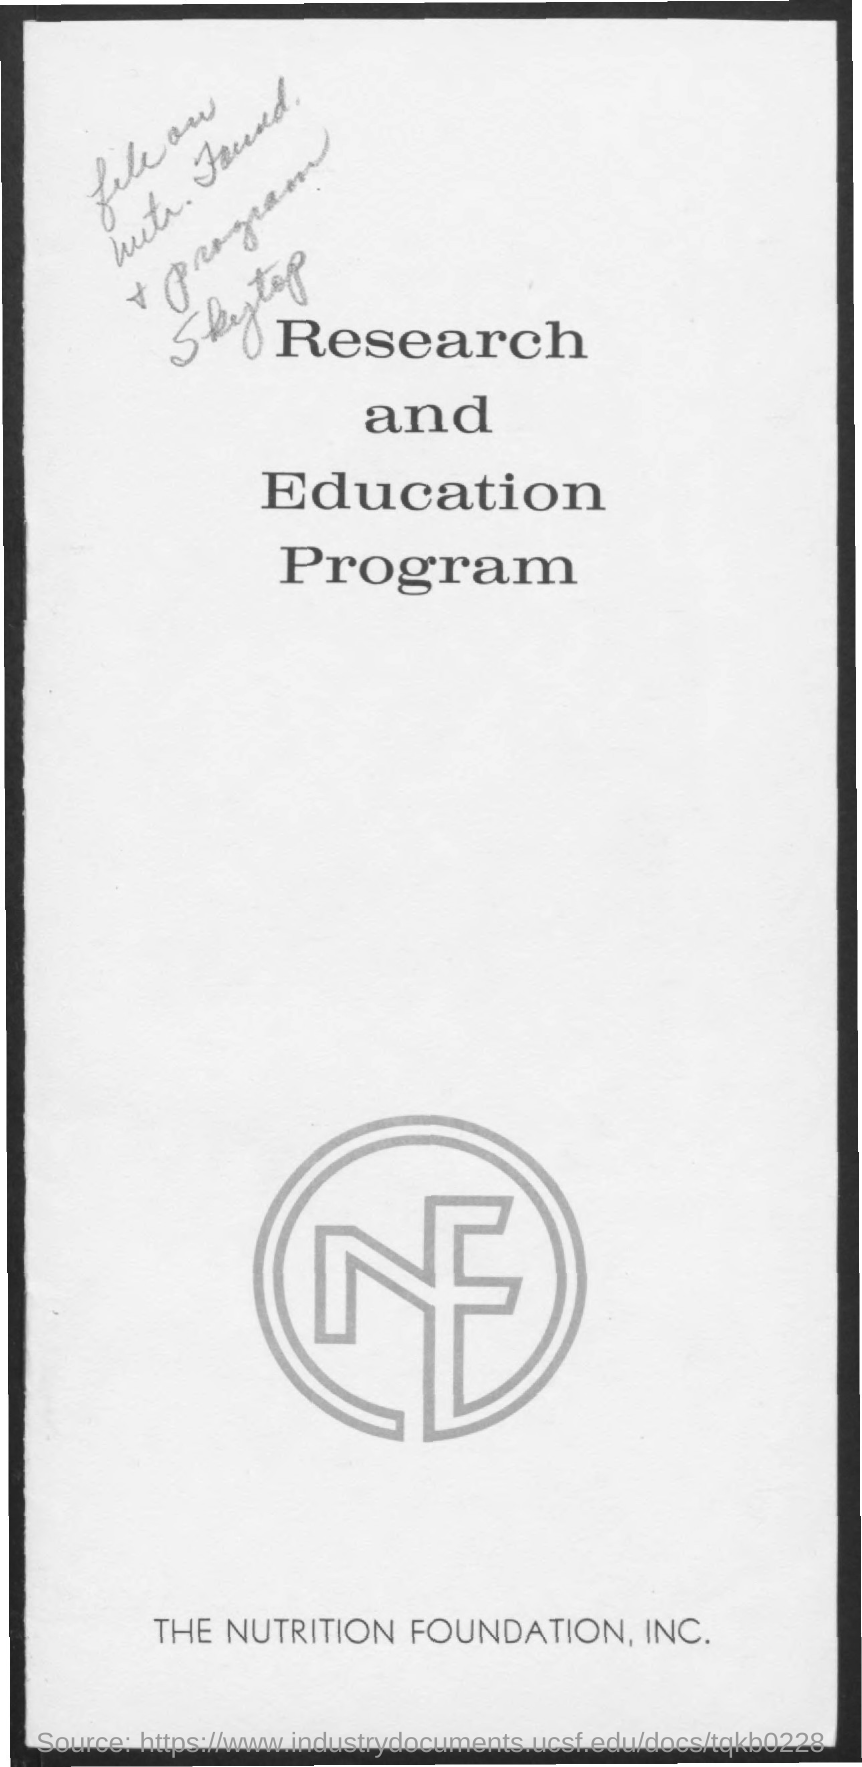Give some essential details in this illustration. The title of the document is 'Research and Education Program.' The Nutrition Foundation, Inc. is the name of the organization listed at the bottom. 